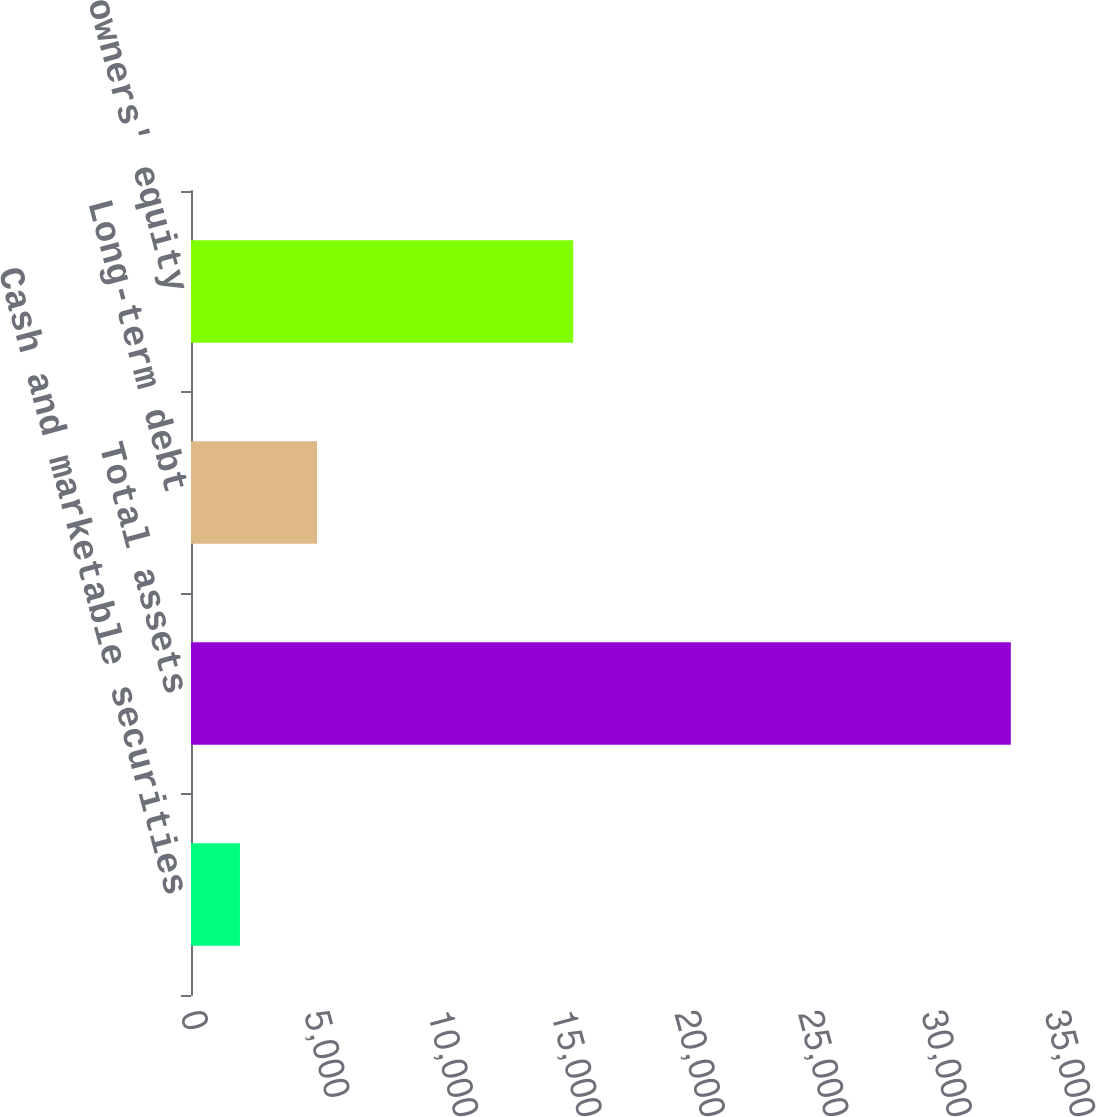Convert chart to OTSL. <chart><loc_0><loc_0><loc_500><loc_500><bar_chart><fcel>Cash and marketable securities<fcel>Total assets<fcel>Long-term debt<fcel>Shareowners' equity<nl><fcel>1983<fcel>33210<fcel>5105.7<fcel>15482<nl></chart> 